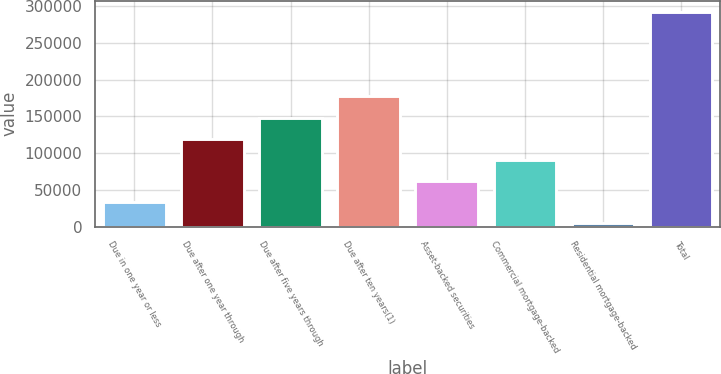Convert chart. <chart><loc_0><loc_0><loc_500><loc_500><bar_chart><fcel>Due in one year or less<fcel>Due after one year through<fcel>Due after five years through<fcel>Due after ten years(1)<fcel>Asset-backed securities<fcel>Commercial mortgage-backed<fcel>Residential mortgage-backed<fcel>Total<nl><fcel>33135.3<fcel>119617<fcel>148444<fcel>177272<fcel>61962.6<fcel>90789.9<fcel>4308<fcel>292581<nl></chart> 